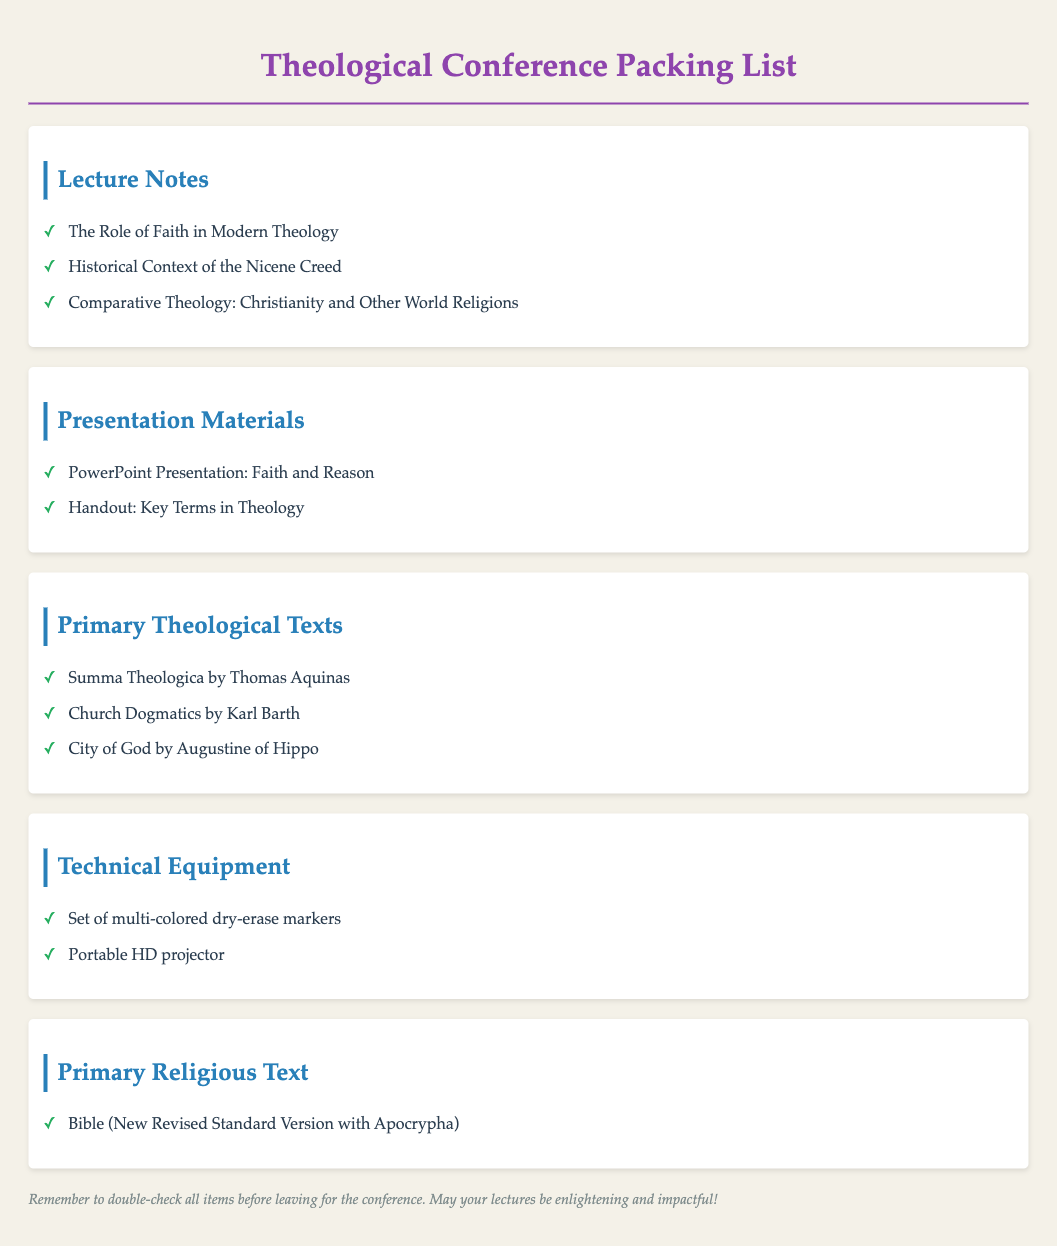What are the titles of the lecture notes? The lecture notes include specific titles listed under that section, showcasing the topics prepared for the conference.
Answer: The Role of Faith in Modern Theology, Historical Context of the Nicene Creed, Comparative Theology: Christianity and Other World Religions What is one of the primary theological texts listed? The packing list specifies primary theological texts that should be brought to the conference, which includes several important works.
Answer: Summa Theologica by Thomas Aquinas How many presentation materials are listed? To find the number of presentation materials, count the items under that section of the document.
Answer: 2 What type of projector is mentioned? The document specifically mentions the type of technical equipment that should be brought to the conference.
Answer: Portable HD projector What is the name of the Bible version to be brought? The packing list specifies the particular version of the Bible to be included, which is important for lectures and discussions.
Answer: New Revised Standard Version with Apocrypha What is one use of the multi-colored dry-erase markers? The inclusion of markers typically implies a use related to presentation or teaching during the conference.
Answer: Writing on a whiteboard or flip chart How many primary theological texts are listed? The number of primary theological texts can be determined by counting them in the corresponding section.
Answer: 3 What is the design purpose of the packing list? The packing list serves as a pre-travel checklist for attendees to ensure they have all necessary materials packed for the conference.
Answer: To ensure all essential items are packed 